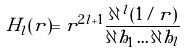Convert formula to latex. <formula><loc_0><loc_0><loc_500><loc_500>H _ { l } ( { r } ) = r ^ { 2 l + 1 } \frac { \partial \, ^ { l } ( 1 / r ) } { \partial h _ { 1 } \dots \partial h _ { l } }</formula> 